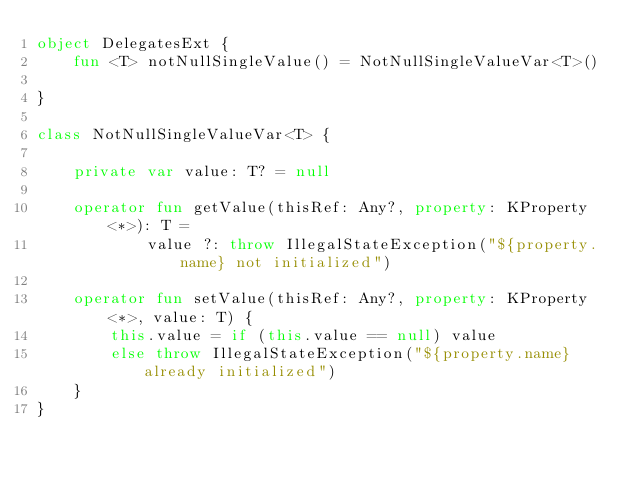Convert code to text. <code><loc_0><loc_0><loc_500><loc_500><_Kotlin_>object DelegatesExt {
    fun <T> notNullSingleValue() = NotNullSingleValueVar<T>()

}

class NotNullSingleValueVar<T> {

    private var value: T? = null

    operator fun getValue(thisRef: Any?, property: KProperty<*>): T =
            value ?: throw IllegalStateException("${property.name} not initialized")

    operator fun setValue(thisRef: Any?, property: KProperty<*>, value: T) {
        this.value = if (this.value == null) value
        else throw IllegalStateException("${property.name} already initialized")
    }
}

</code> 